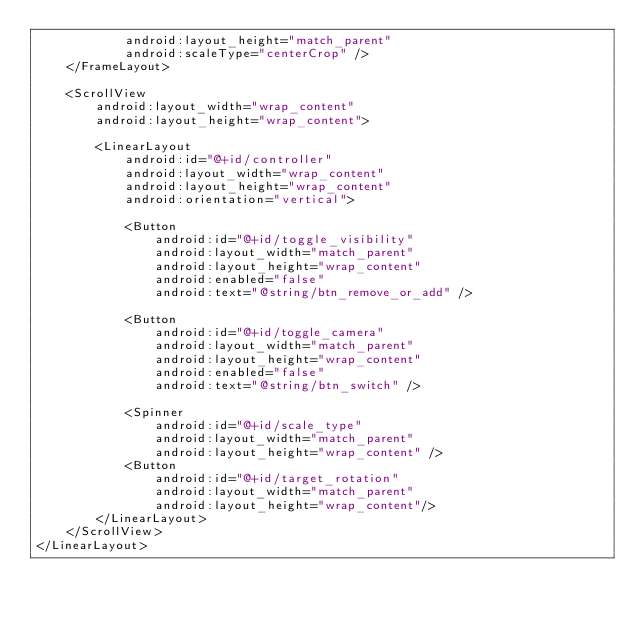<code> <loc_0><loc_0><loc_500><loc_500><_XML_>            android:layout_height="match_parent"
            android:scaleType="centerCrop" />
    </FrameLayout>

    <ScrollView
        android:layout_width="wrap_content"
        android:layout_height="wrap_content">

        <LinearLayout
            android:id="@+id/controller"
            android:layout_width="wrap_content"
            android:layout_height="wrap_content"
            android:orientation="vertical">

            <Button
                android:id="@+id/toggle_visibility"
                android:layout_width="match_parent"
                android:layout_height="wrap_content"
                android:enabled="false"
                android:text="@string/btn_remove_or_add" />

            <Button
                android:id="@+id/toggle_camera"
                android:layout_width="match_parent"
                android:layout_height="wrap_content"
                android:enabled="false"
                android:text="@string/btn_switch" />

            <Spinner
                android:id="@+id/scale_type"
                android:layout_width="match_parent"
                android:layout_height="wrap_content" />
            <Button
                android:id="@+id/target_rotation"
                android:layout_width="match_parent"
                android:layout_height="wrap_content"/>
        </LinearLayout>
    </ScrollView>
</LinearLayout>
</code> 